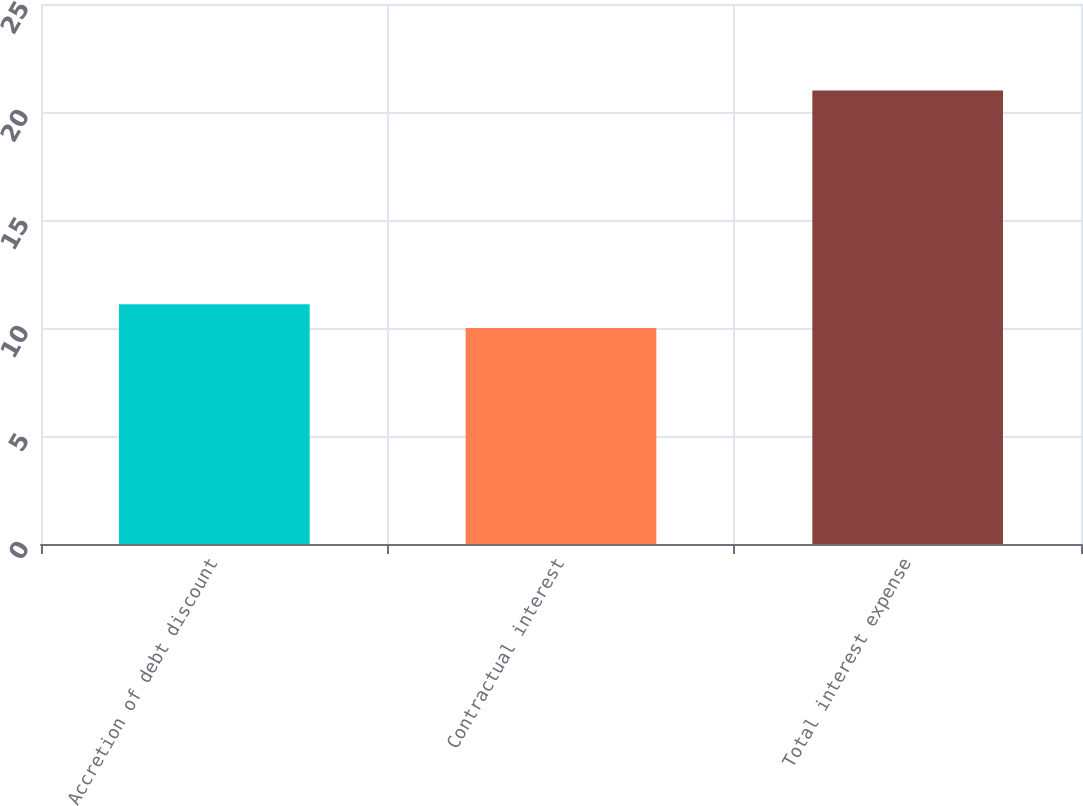Convert chart to OTSL. <chart><loc_0><loc_0><loc_500><loc_500><bar_chart><fcel>Accretion of debt discount<fcel>Contractual interest<fcel>Total interest expense<nl><fcel>11.1<fcel>10<fcel>21<nl></chart> 